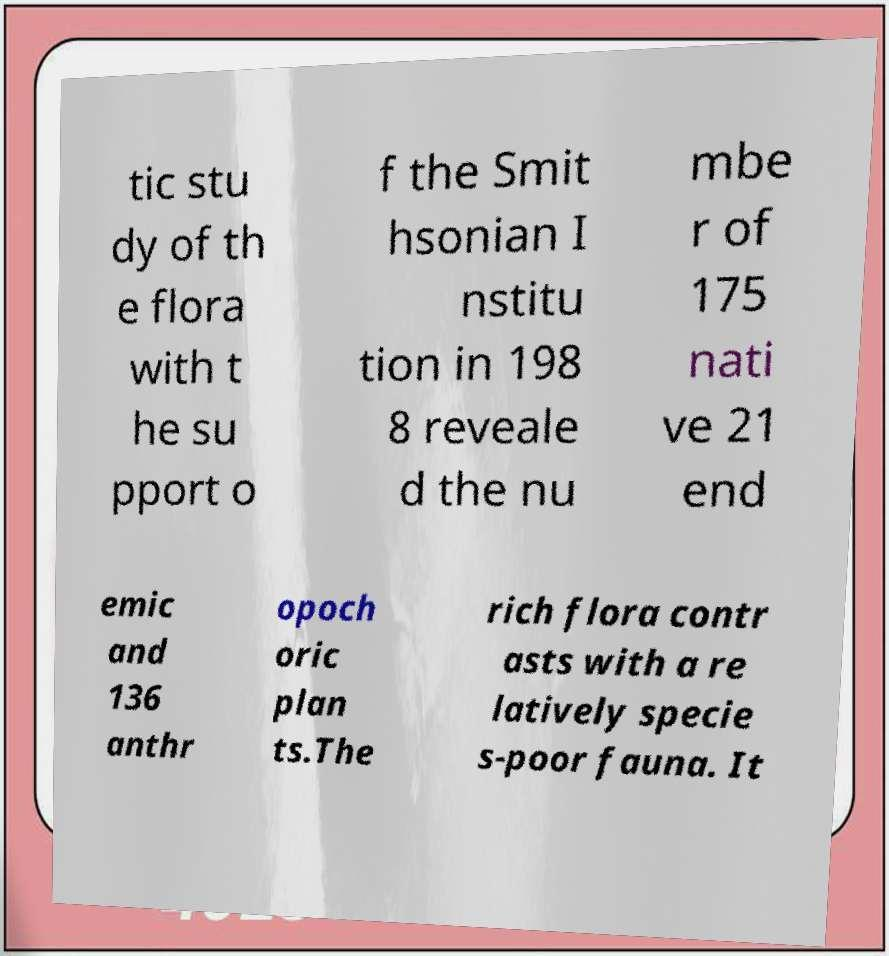Can you read and provide the text displayed in the image?This photo seems to have some interesting text. Can you extract and type it out for me? tic stu dy of th e flora with t he su pport o f the Smit hsonian I nstitu tion in 198 8 reveale d the nu mbe r of 175 nati ve 21 end emic and 136 anthr opoch oric plan ts.The rich flora contr asts with a re latively specie s-poor fauna. It 